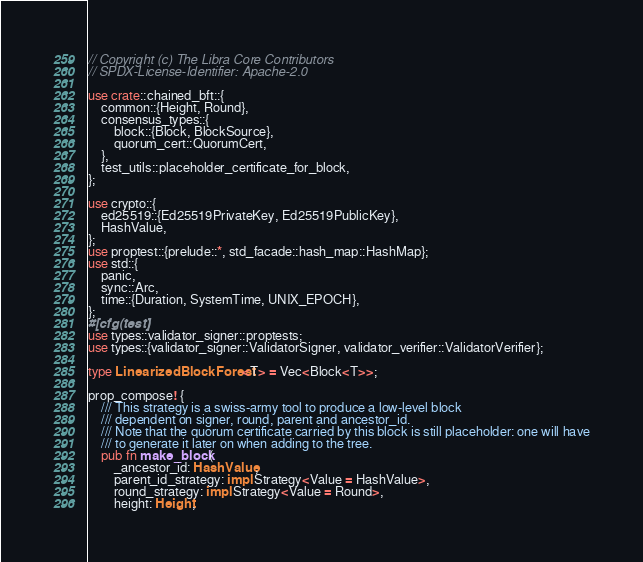<code> <loc_0><loc_0><loc_500><loc_500><_Rust_>// Copyright (c) The Libra Core Contributors
// SPDX-License-Identifier: Apache-2.0

use crate::chained_bft::{
    common::{Height, Round},
    consensus_types::{
        block::{Block, BlockSource},
        quorum_cert::QuorumCert,
    },
    test_utils::placeholder_certificate_for_block,
};

use crypto::{
    ed25519::{Ed25519PrivateKey, Ed25519PublicKey},
    HashValue,
};
use proptest::{prelude::*, std_facade::hash_map::HashMap};
use std::{
    panic,
    sync::Arc,
    time::{Duration, SystemTime, UNIX_EPOCH},
};
#[cfg(test)]
use types::validator_signer::proptests;
use types::{validator_signer::ValidatorSigner, validator_verifier::ValidatorVerifier};

type LinearizedBlockForest<T> = Vec<Block<T>>;

prop_compose! {
    /// This strategy is a swiss-army tool to produce a low-level block
    /// dependent on signer, round, parent and ancestor_id.
    /// Note that the quorum certificate carried by this block is still placeholder: one will have
    /// to generate it later on when adding to the tree.
    pub fn make_block(
        _ancestor_id: HashValue,
        parent_id_strategy: impl Strategy<Value = HashValue>,
        round_strategy: impl Strategy<Value = Round>,
        height: Height,</code> 